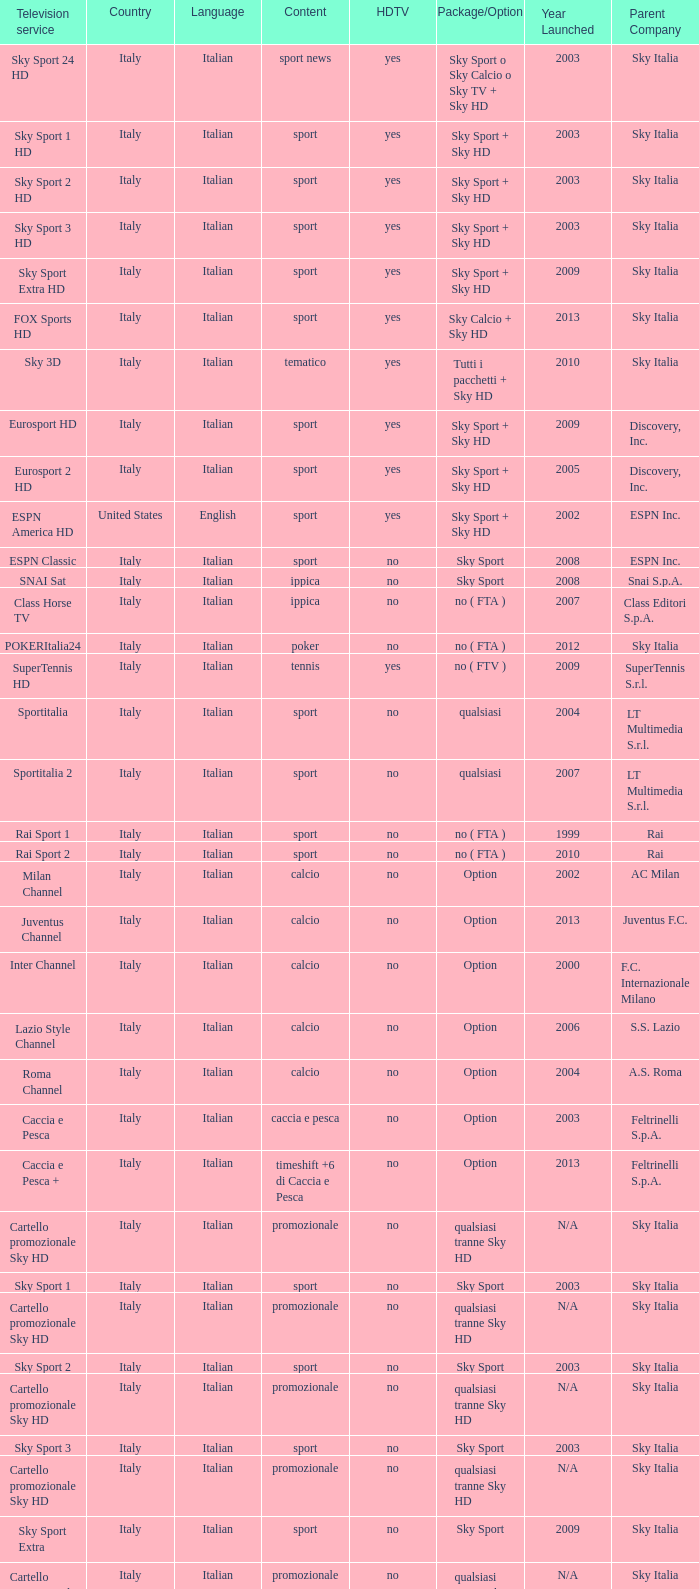What does package/option refer to when the content is related to poker? No ( fta ). 